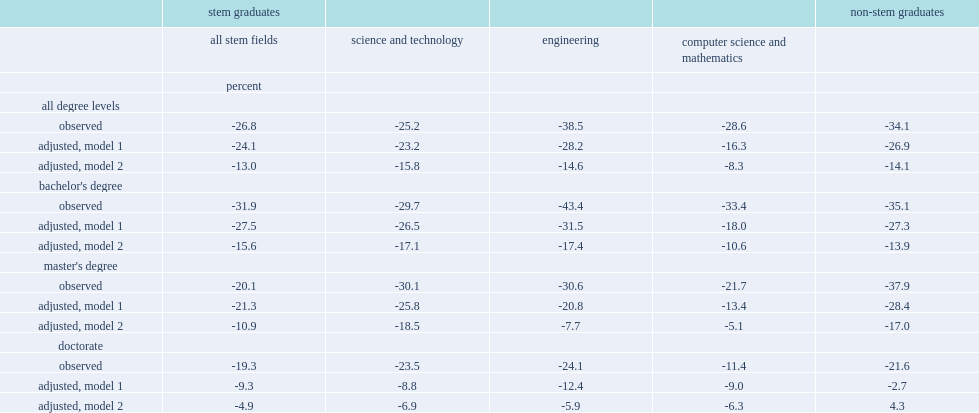Among all degree level, which degree holders did the worse job? Bachelor's degree. What is the gap of engineers with a bachelor's degree that fared the worst overall? -43.4. What is the gap for immigrant engineers with a doctorate? -24.1. Which field of study can find the greatest gap between the immigrant-canadian-born earnings? Engineering. 